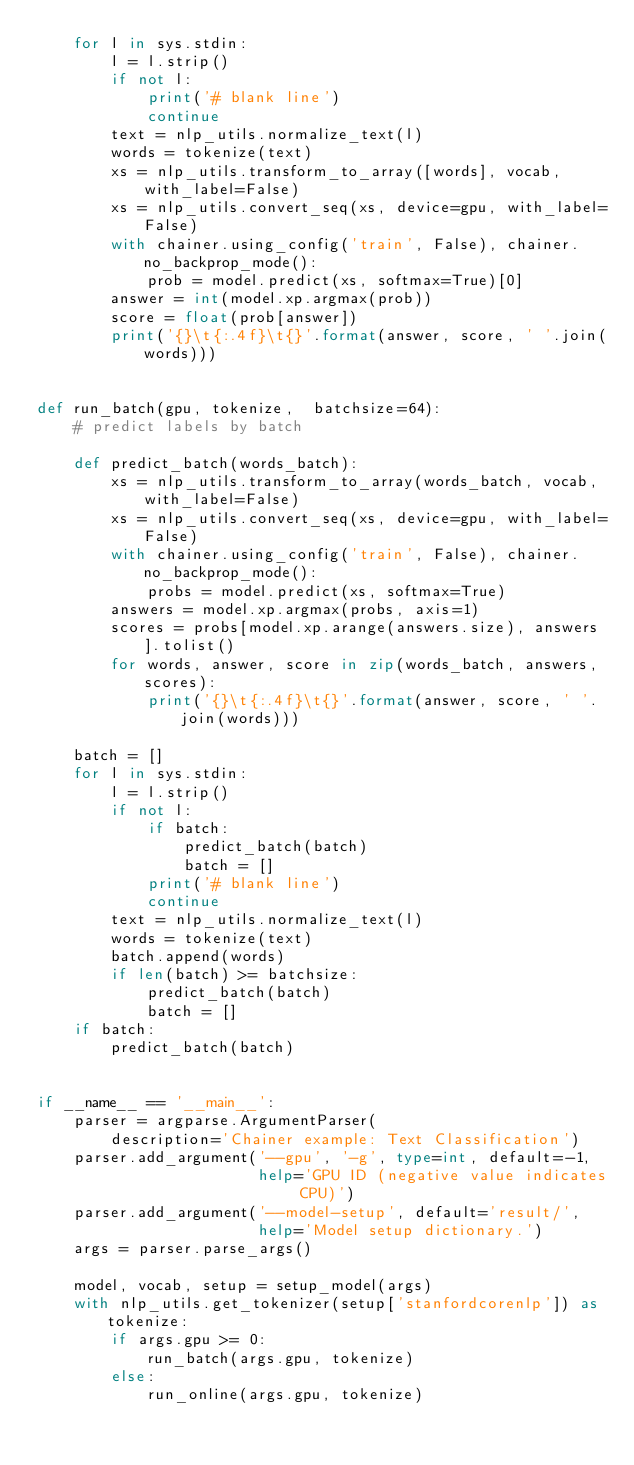Convert code to text. <code><loc_0><loc_0><loc_500><loc_500><_Python_>    for l in sys.stdin:
        l = l.strip()
        if not l:
            print('# blank line')
            continue
        text = nlp_utils.normalize_text(l)
        words = tokenize(text)
        xs = nlp_utils.transform_to_array([words], vocab, with_label=False)
        xs = nlp_utils.convert_seq(xs, device=gpu, with_label=False)
        with chainer.using_config('train', False), chainer.no_backprop_mode():
            prob = model.predict(xs, softmax=True)[0]
        answer = int(model.xp.argmax(prob))
        score = float(prob[answer])
        print('{}\t{:.4f}\t{}'.format(answer, score, ' '.join(words)))


def run_batch(gpu, tokenize,  batchsize=64):
    # predict labels by batch

    def predict_batch(words_batch):
        xs = nlp_utils.transform_to_array(words_batch, vocab, with_label=False)
        xs = nlp_utils.convert_seq(xs, device=gpu, with_label=False)
        with chainer.using_config('train', False), chainer.no_backprop_mode():
            probs = model.predict(xs, softmax=True)
        answers = model.xp.argmax(probs, axis=1)
        scores = probs[model.xp.arange(answers.size), answers].tolist()
        for words, answer, score in zip(words_batch, answers, scores):
            print('{}\t{:.4f}\t{}'.format(answer, score, ' '.join(words)))

    batch = []
    for l in sys.stdin:
        l = l.strip()
        if not l:
            if batch:
                predict_batch(batch)
                batch = []
            print('# blank line')
            continue
        text = nlp_utils.normalize_text(l)
        words = tokenize(text)
        batch.append(words)
        if len(batch) >= batchsize:
            predict_batch(batch)
            batch = []
    if batch:
        predict_batch(batch)


if __name__ == '__main__':
    parser = argparse.ArgumentParser(
        description='Chainer example: Text Classification')
    parser.add_argument('--gpu', '-g', type=int, default=-1,
                        help='GPU ID (negative value indicates CPU)')
    parser.add_argument('--model-setup', default='result/',
                        help='Model setup dictionary.')
    args = parser.parse_args()

    model, vocab, setup = setup_model(args)
    with nlp_utils.get_tokenizer(setup['stanfordcorenlp']) as tokenize:
        if args.gpu >= 0:
            run_batch(args.gpu, tokenize)
        else:
            run_online(args.gpu, tokenize)
</code> 